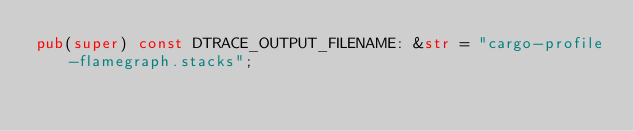<code> <loc_0><loc_0><loc_500><loc_500><_Rust_>pub(super) const DTRACE_OUTPUT_FILENAME: &str = "cargo-profile-flamegraph.stacks";
</code> 